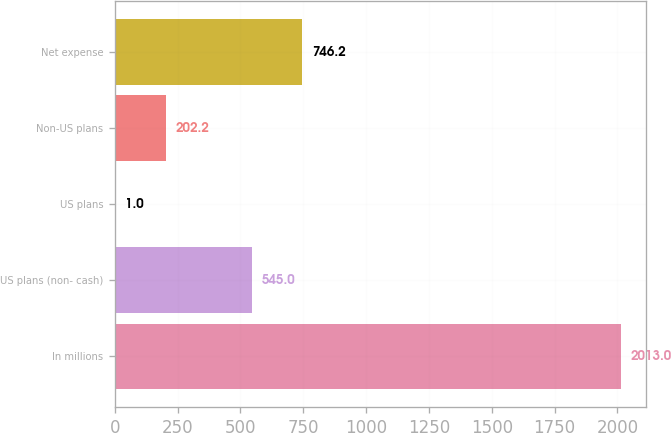Convert chart. <chart><loc_0><loc_0><loc_500><loc_500><bar_chart><fcel>In millions<fcel>US plans (non- cash)<fcel>US plans<fcel>Non-US plans<fcel>Net expense<nl><fcel>2013<fcel>545<fcel>1<fcel>202.2<fcel>746.2<nl></chart> 